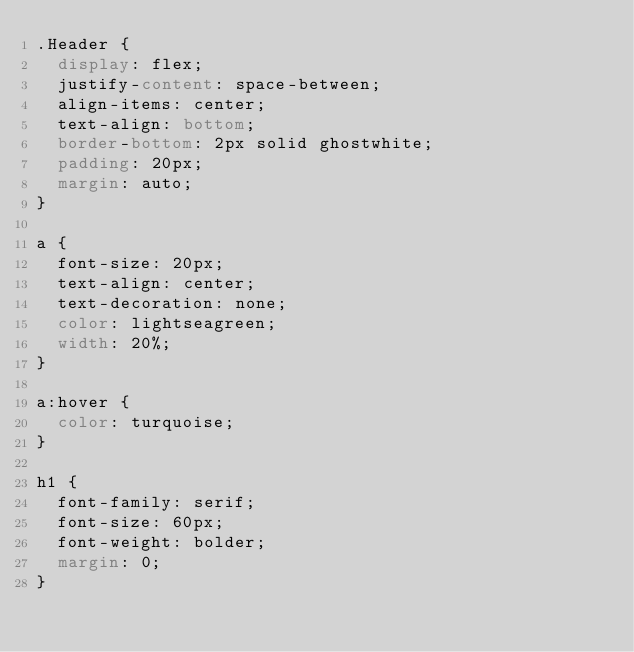<code> <loc_0><loc_0><loc_500><loc_500><_CSS_>.Header {
  display: flex;
  justify-content: space-between;
  align-items: center;
  text-align: bottom;
  border-bottom: 2px solid ghostwhite;
  padding: 20px;
  margin: auto;
}

a {
  font-size: 20px;  
  text-align: center;
  text-decoration: none;
  color: lightseagreen;
  width: 20%;
}

a:hover {
  color: turquoise;
}

h1 {
  font-family: serif;
  font-size: 60px;
  font-weight: bolder;
  margin: 0;
}</code> 